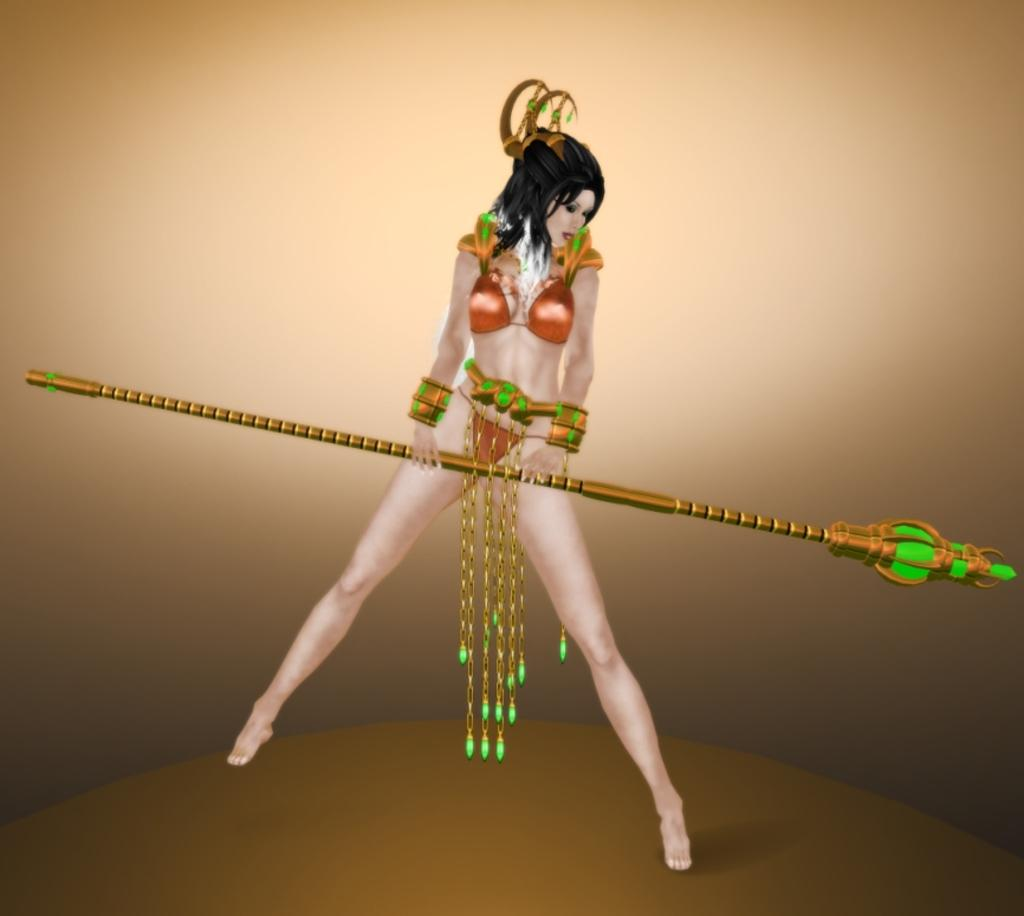Who is the main subject in the image? There is a woman in the image. What is the woman doing in the image? The woman is standing in the image. What object is the woman holding in the image? The woman is holding a magic stick in the image. Can you describe the background of the image? The background of the image is creamy. What type of volleyball game is being played in the background of the image? There is no volleyball game present in the image. What season is depicted in the image, considering the background? The background does not provide any information about the season, as it is described as creamy. 